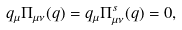Convert formula to latex. <formula><loc_0><loc_0><loc_500><loc_500>q _ { \mu } \Pi _ { \mu \nu } ( q ) = q _ { \mu } \Pi ^ { s } _ { \mu \nu } ( q ) = 0 ,</formula> 